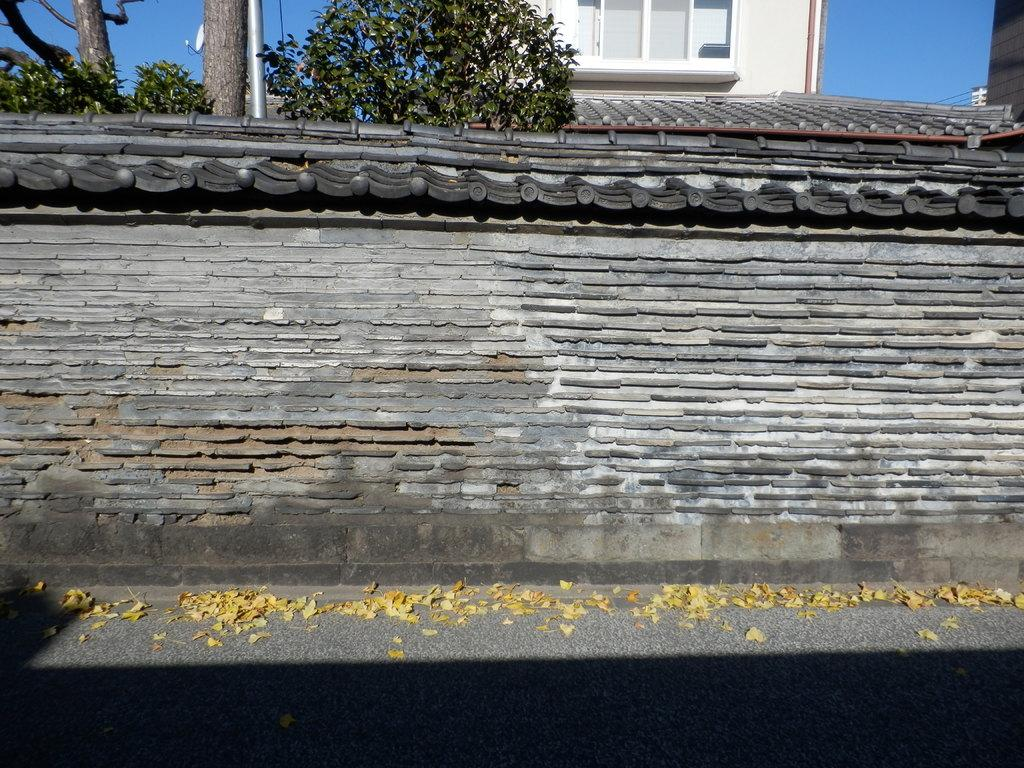What is in the foreground of the image? There is a road in the foreground of the image. What can be seen on the road? There are dry leaves on the road. What is located in the middle of the image? There is a wall in the middle of the image. What is visible at the top of the image? There is a roof, trees, a pole, and the sky visible at the top of the image. What type of cherry is being used as a notebook in the image? There is no cherry or notebook present in the image. What invention is being demonstrated in the image? There is no invention being demonstrated in the image. 